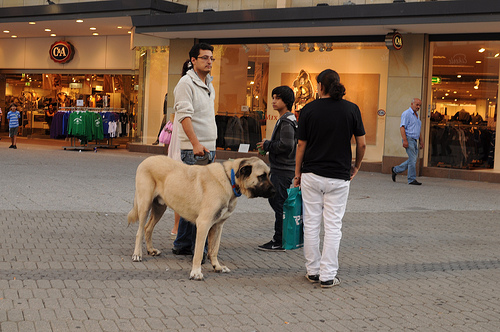Is the kid to the right or to the left of the person that is wearing a shirt? The kid is to the left of the person wearing a shirt, close by and engaged in the group's activity. 